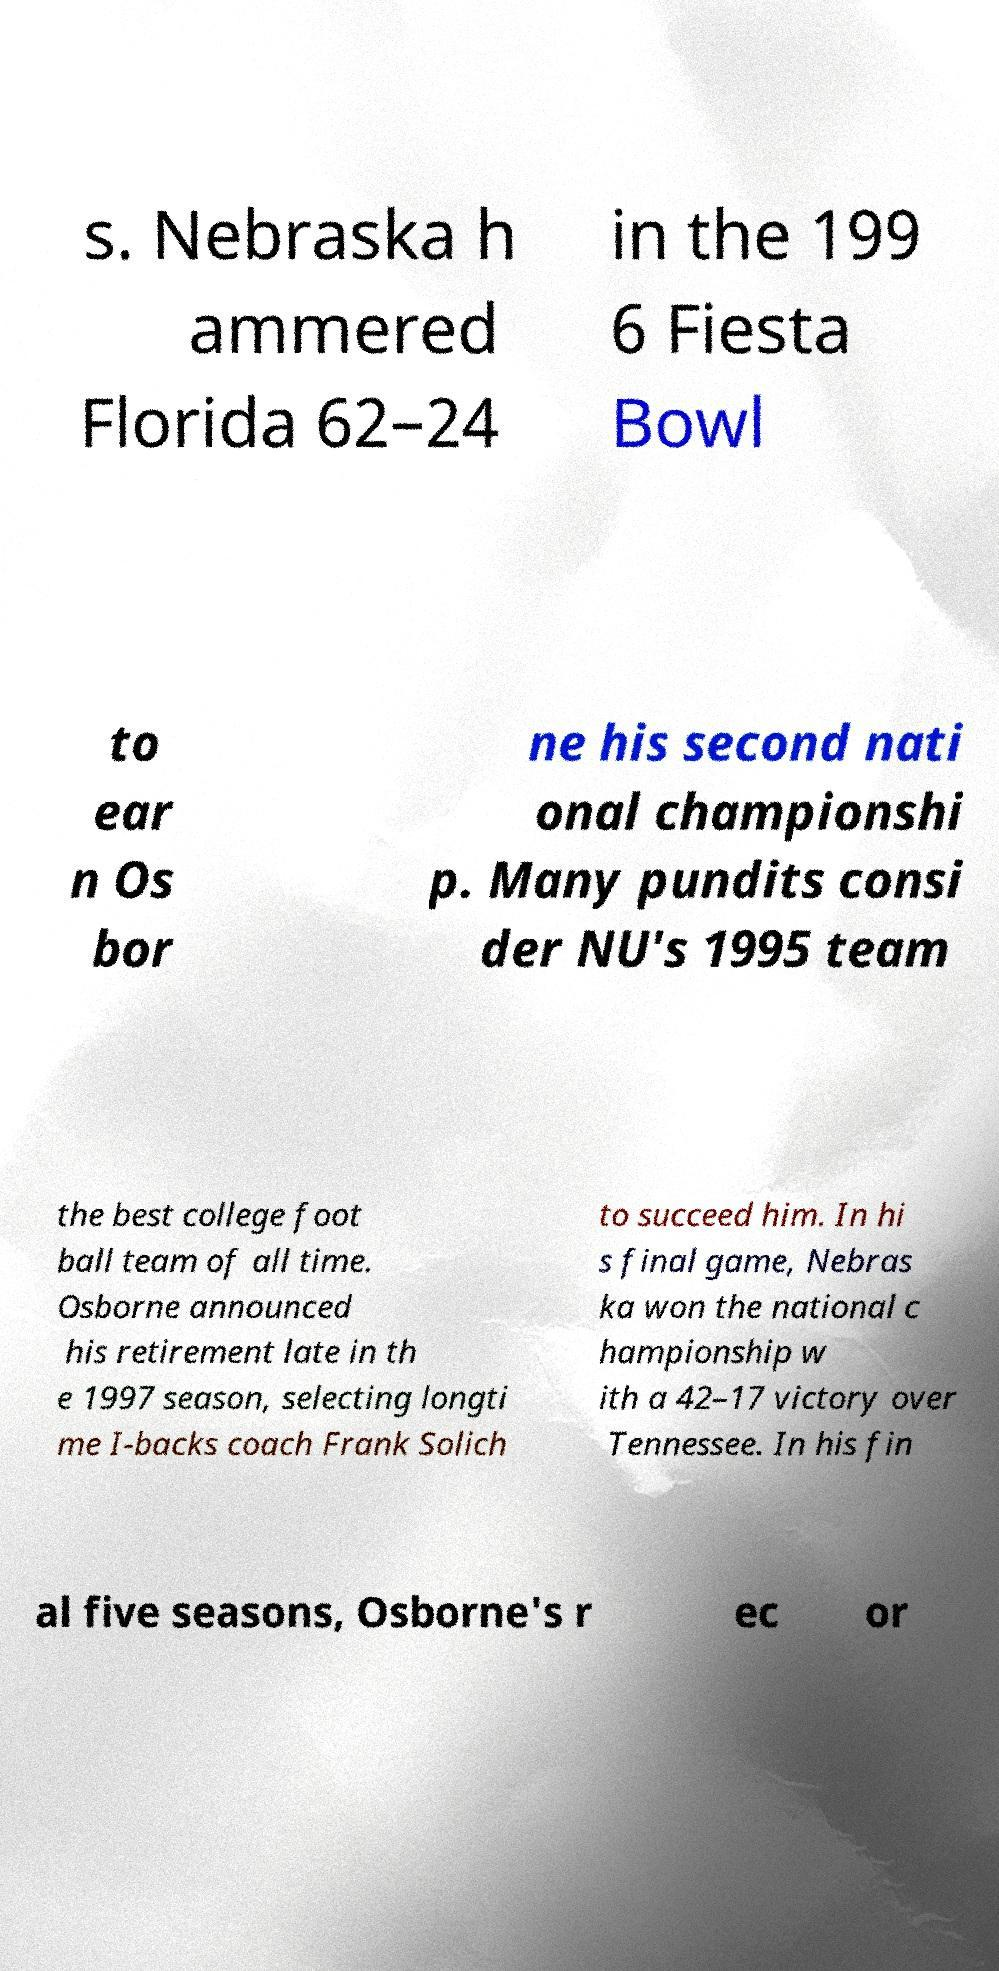I need the written content from this picture converted into text. Can you do that? s. Nebraska h ammered Florida 62–24 in the 199 6 Fiesta Bowl to ear n Os bor ne his second nati onal championshi p. Many pundits consi der NU's 1995 team the best college foot ball team of all time. Osborne announced his retirement late in th e 1997 season, selecting longti me I-backs coach Frank Solich to succeed him. In hi s final game, Nebras ka won the national c hampionship w ith a 42–17 victory over Tennessee. In his fin al five seasons, Osborne's r ec or 